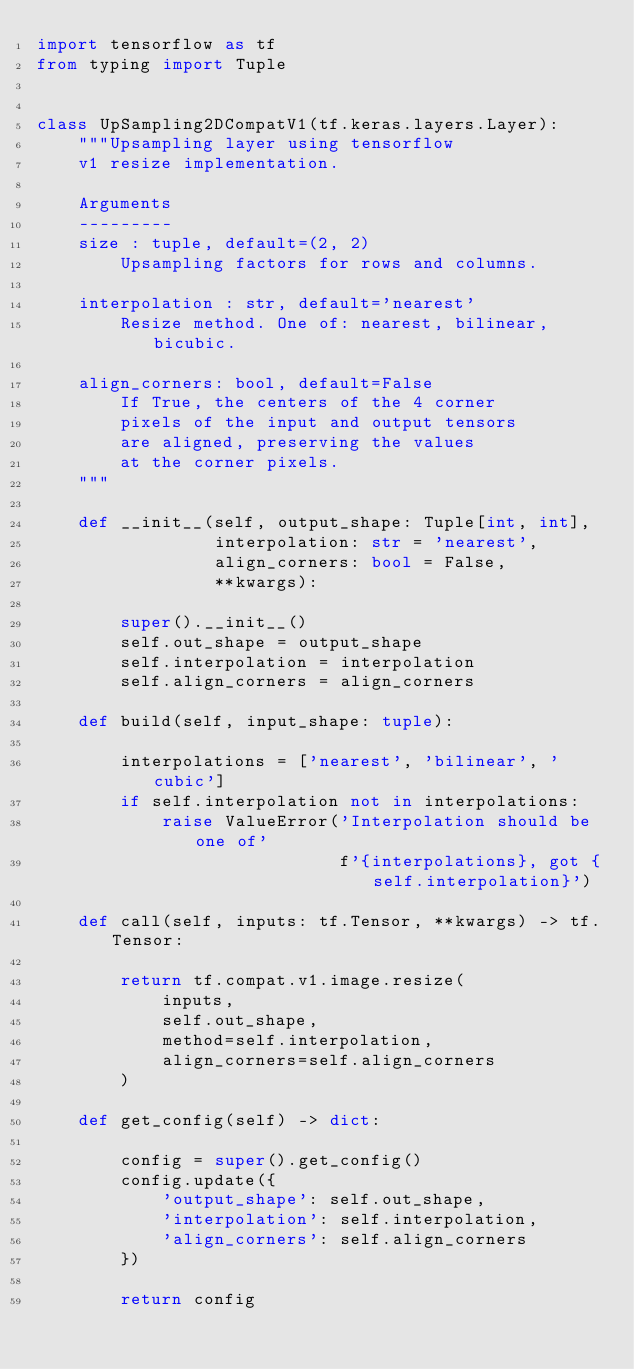Convert code to text. <code><loc_0><loc_0><loc_500><loc_500><_Python_>import tensorflow as tf
from typing import Tuple


class UpSampling2DCompatV1(tf.keras.layers.Layer):
    """Upsampling layer using tensorflow
    v1 resize implementation.

    Arguments
    ---------
    size : tuple, default=(2, 2)
        Upsampling factors for rows and columns.

    interpolation : str, default='nearest'
        Resize method. One of: nearest, bilinear, bicubic.

    align_corners: bool, default=False
        If True, the centers of the 4 corner
        pixels of the input and output tensors
        are aligned, preserving the values
        at the corner pixels.
    """

    def __init__(self, output_shape: Tuple[int, int],
                 interpolation: str = 'nearest',
                 align_corners: bool = False,
                 **kwargs):

        super().__init__()
        self.out_shape = output_shape
        self.interpolation = interpolation
        self.align_corners = align_corners

    def build(self, input_shape: tuple):

        interpolations = ['nearest', 'bilinear', 'cubic']
        if self.interpolation not in interpolations:
            raise ValueError('Interpolation should be one of'
                             f'{interpolations}, got {self.interpolation}')

    def call(self, inputs: tf.Tensor, **kwargs) -> tf.Tensor:

        return tf.compat.v1.image.resize(
            inputs,
            self.out_shape,
            method=self.interpolation,
            align_corners=self.align_corners
        )

    def get_config(self) -> dict:

        config = super().get_config()
        config.update({
            'output_shape': self.out_shape,
            'interpolation': self.interpolation,
            'align_corners': self.align_corners
        })

        return config
</code> 